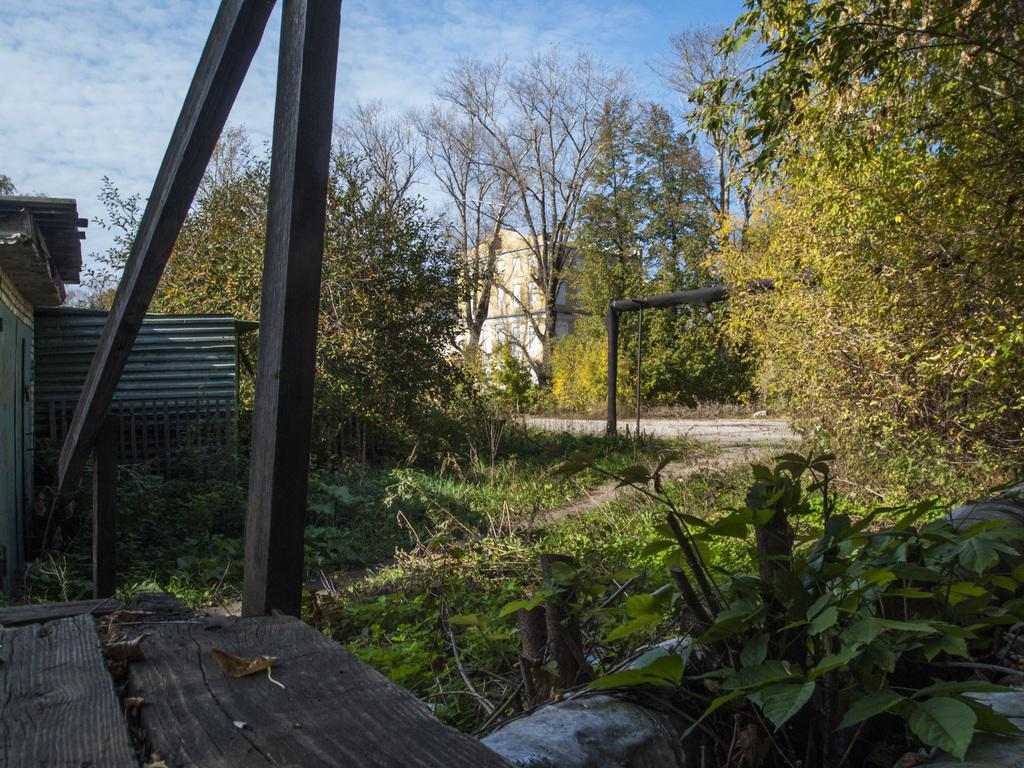What type of vegetation can be seen in the image? There are trees in the image. What material is used for the planks in the image? The wooden planks in the image are made of wood. What is covering the top of the building in the image? Roof sheets are present in the image, covering the top of the building. What type of structure is visible in the image? There is a building in the image. What is visible on the ground in the image? Grass is visible in the image. What can be seen in the background of the image? The sky with clouds is visible in the background of the image. What type of animal is playing the piano in the image? There is no animal or piano present in the image. 